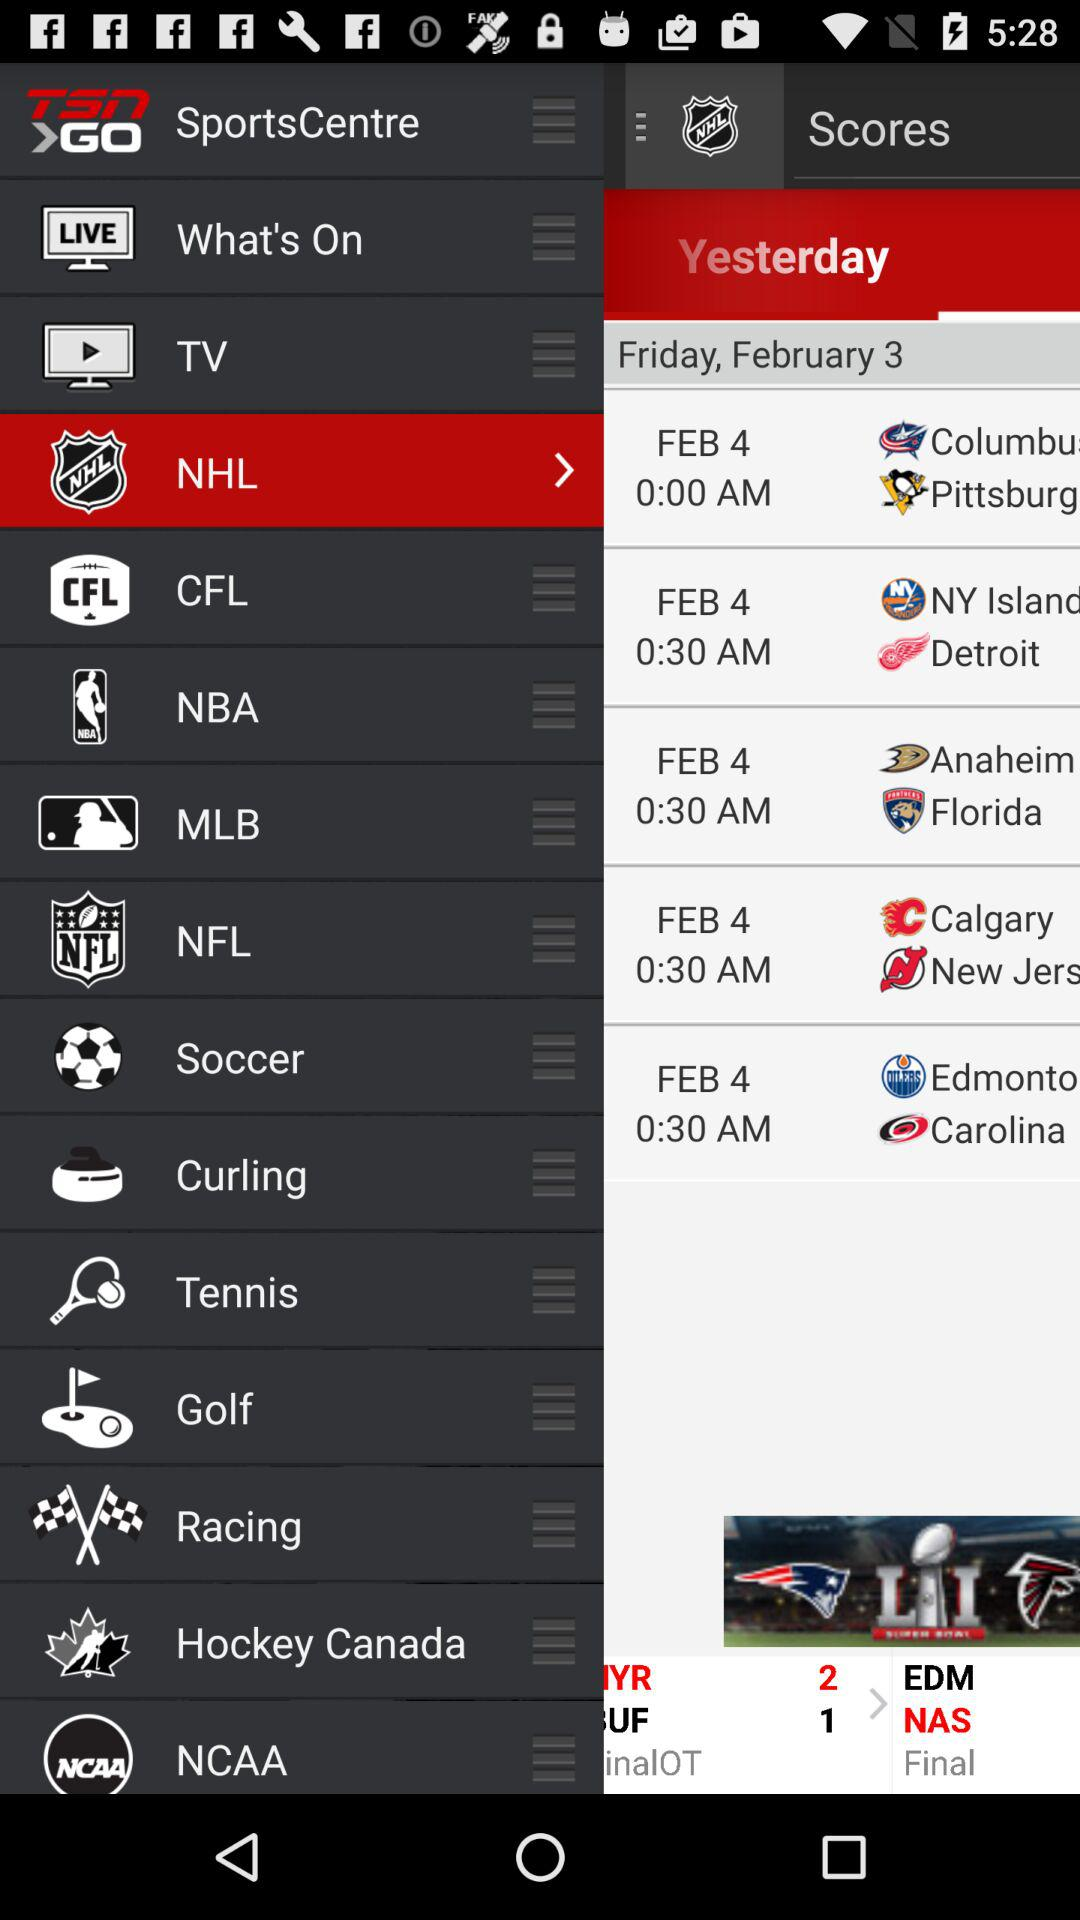What day falls on February 3? The day is Friday. 